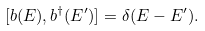<formula> <loc_0><loc_0><loc_500><loc_500>[ b ( E ) , b ^ { \dagger } ( E ^ { \prime } ) ] = \delta ( E - E ^ { \prime } ) .</formula> 